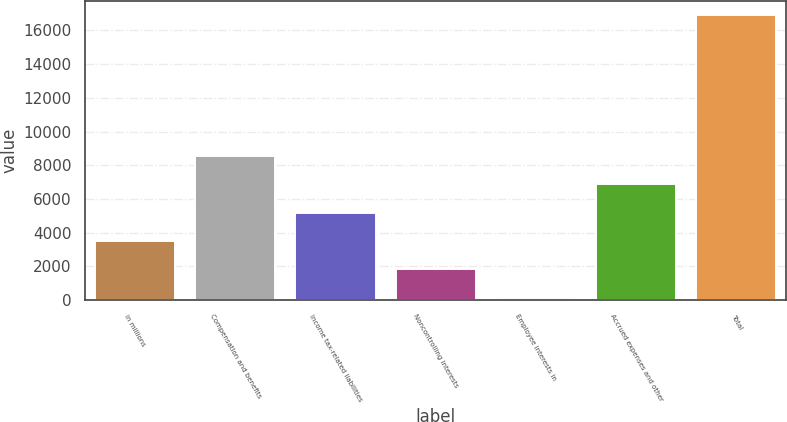Convert chart. <chart><loc_0><loc_0><loc_500><loc_500><bar_chart><fcel>in millions<fcel>Compensation and benefits<fcel>Income tax-related liabilities<fcel>Noncontrolling interests<fcel>Employee interests in<fcel>Accrued expenses and other<fcel>Total<nl><fcel>3509.2<fcel>8539<fcel>5185.8<fcel>1832.6<fcel>156<fcel>6862.4<fcel>16922<nl></chart> 